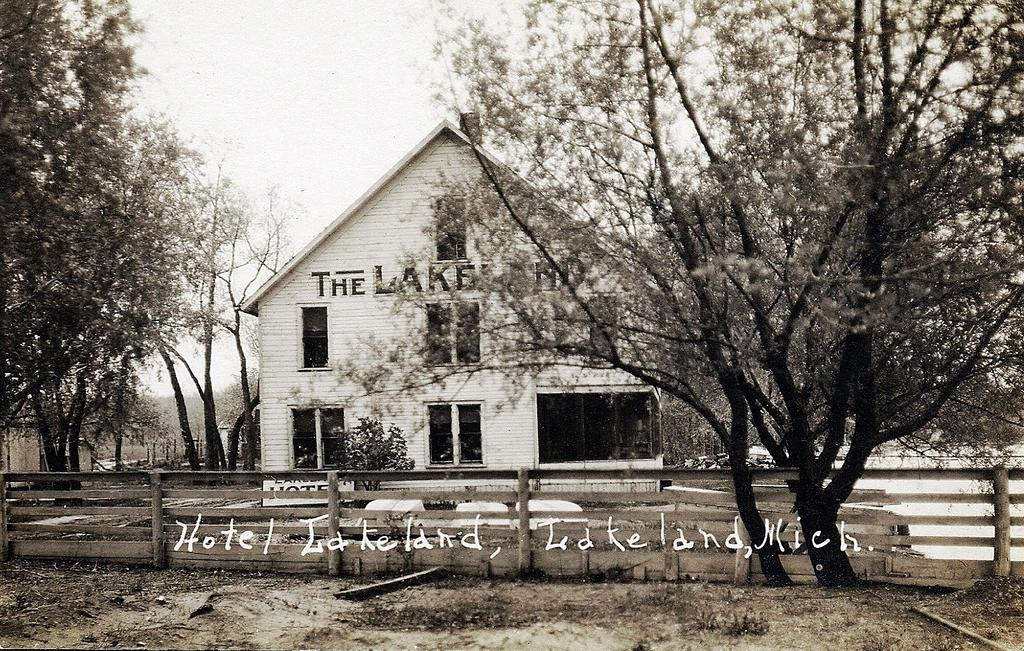<image>
Share a concise interpretation of the image provided. House that is fenced in with a hotel and lake wrote on it 